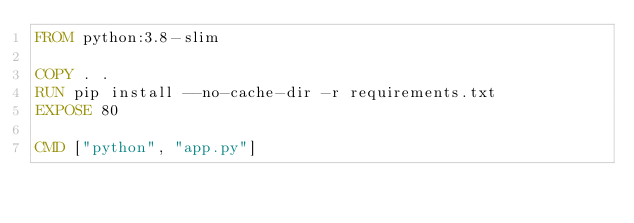Convert code to text. <code><loc_0><loc_0><loc_500><loc_500><_Dockerfile_>FROM python:3.8-slim

COPY . .
RUN pip install --no-cache-dir -r requirements.txt
EXPOSE 80

CMD ["python", "app.py"]</code> 